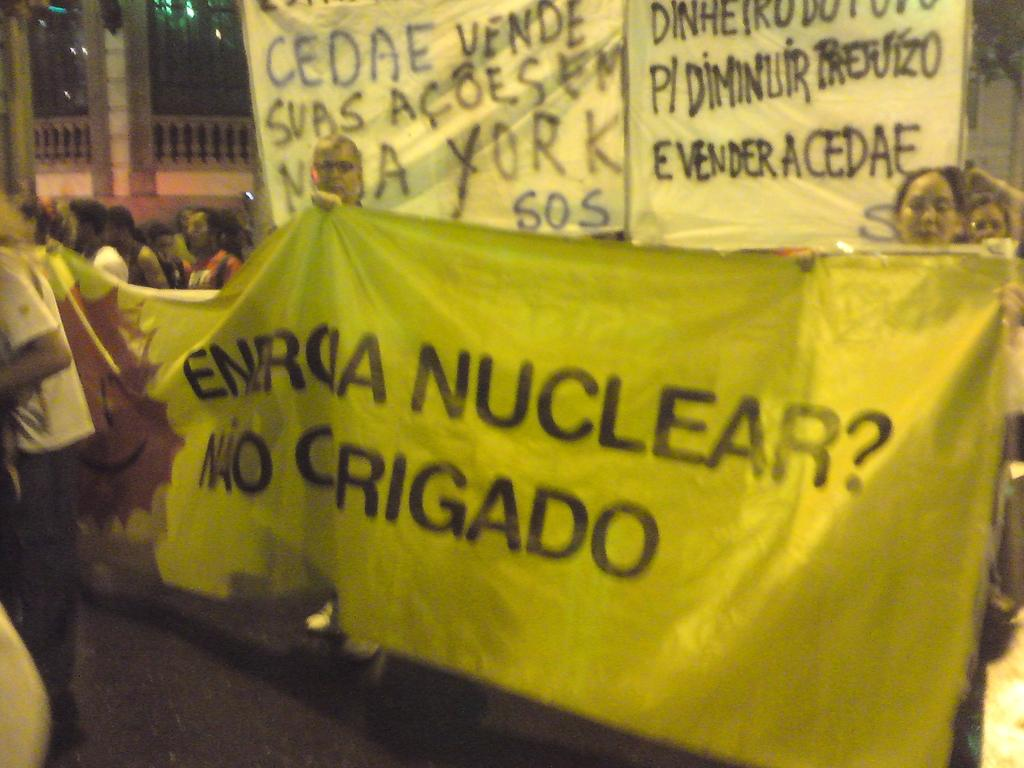How many people are present in the image? There are many people in the image. What are the people wearing? The people are wearing clothes. What type of path can be seen in the image? There is a footpath in the image. What is hanging or displayed in the image? There is a banner in the image. What type of barrier is present in the image? There is a fence in the image. What can be seen that indicates the presence of light? There is light visible in the image. Can you see any feathers on the people in the image? There are no feathers visible on the people in the image. What type of box is being used by the people in the image? There is no box present in the image. Is there a snail crawling on the footpath in the image? There is no snail visible on the footpath in the image. 